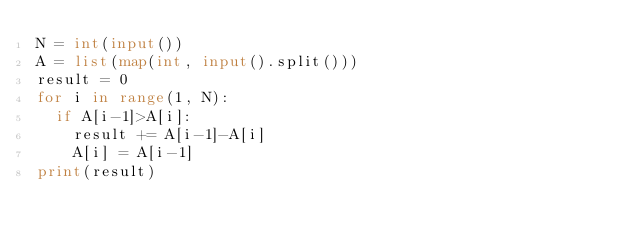Convert code to text. <code><loc_0><loc_0><loc_500><loc_500><_Python_>N = int(input())
A = list(map(int, input().split()))
result = 0
for i in range(1, N):
  if A[i-1]>A[i]:
    result += A[i-1]-A[i]
    A[i] = A[i-1]
print(result)</code> 